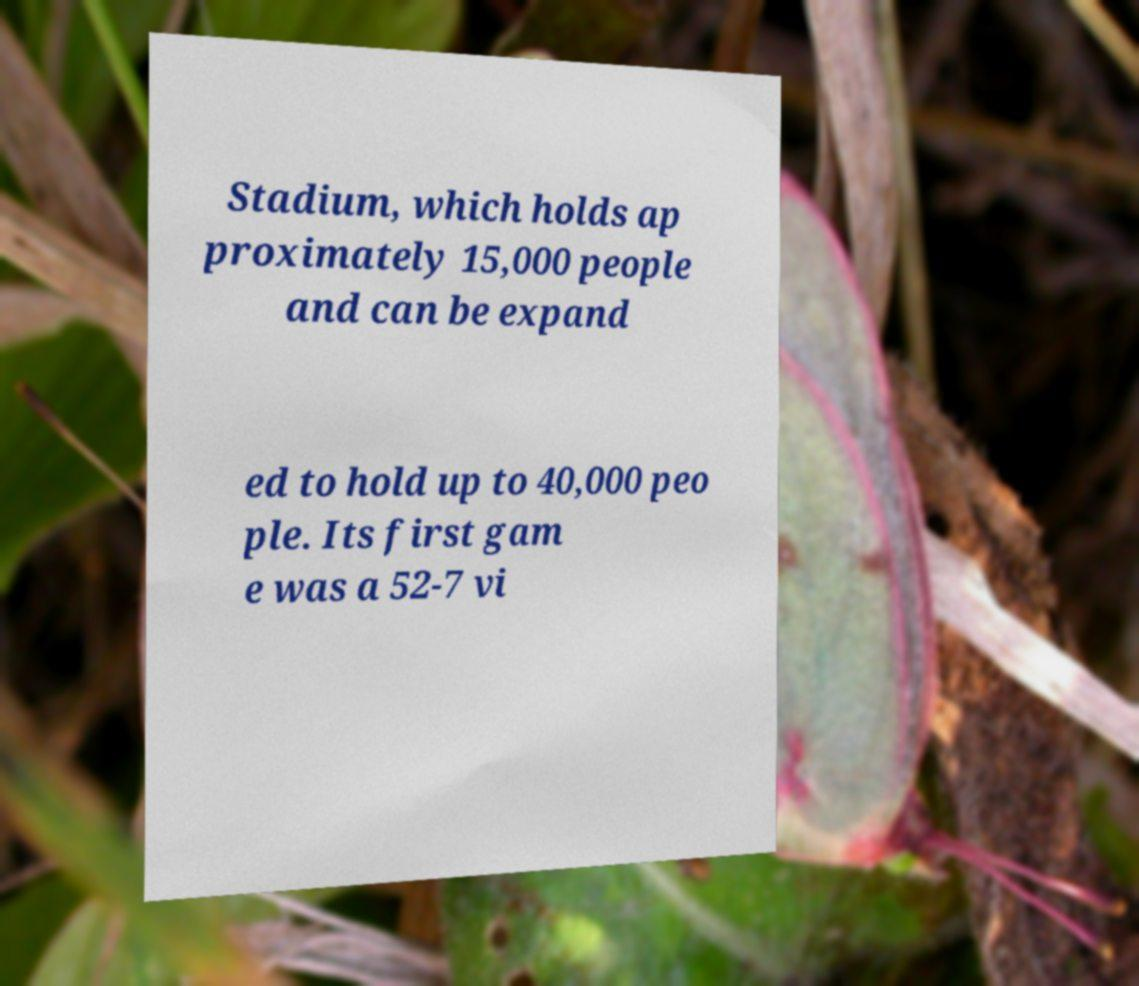Can you read and provide the text displayed in the image?This photo seems to have some interesting text. Can you extract and type it out for me? Stadium, which holds ap proximately 15,000 people and can be expand ed to hold up to 40,000 peo ple. Its first gam e was a 52-7 vi 